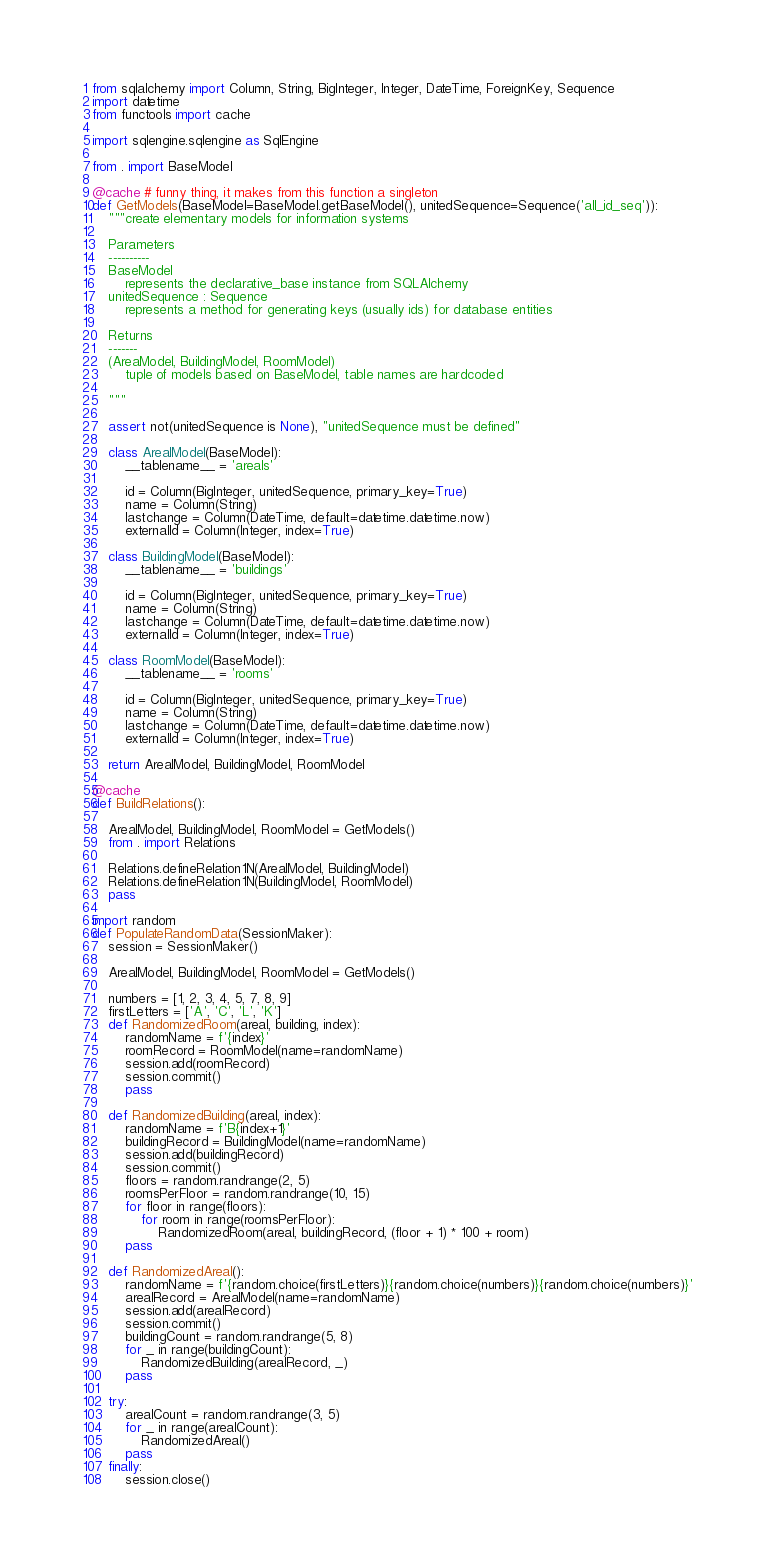<code> <loc_0><loc_0><loc_500><loc_500><_Python_>from sqlalchemy import Column, String, BigInteger, Integer, DateTime, ForeignKey, Sequence
import datetime
from functools import cache

import sqlengine.sqlengine as SqlEngine

from . import BaseModel

@cache # funny thing, it makes from this function a singleton
def GetModels(BaseModel=BaseModel.getBaseModel(), unitedSequence=Sequence('all_id_seq')):
    """create elementary models for information systems

    Parameters
    ----------
    BaseModel
        represents the declarative_base instance from SQLAlchemy
    unitedSequence : Sequence
        represents a method for generating keys (usually ids) for database entities

    Returns
    -------
    (AreaModel, BuildingModel, RoomModel)
        tuple of models based on BaseModel, table names are hardcoded

    """

    assert not(unitedSequence is None), "unitedSequence must be defined"
    
    class ArealModel(BaseModel):
        __tablename__ = 'areals'

        id = Column(BigInteger, unitedSequence, primary_key=True)
        name = Column(String)
        lastchange = Column(DateTime, default=datetime.datetime.now)
        externalId = Column(Integer, index=True)

    class BuildingModel(BaseModel):
        __tablename__ = 'buildings'

        id = Column(BigInteger, unitedSequence, primary_key=True)
        name = Column(String)
        lastchange = Column(DateTime, default=datetime.datetime.now)
        externalId = Column(Integer, index=True)

    class RoomModel(BaseModel):
        __tablename__ = 'rooms'
        
        id = Column(BigInteger, unitedSequence, primary_key=True)
        name = Column(String)
        lastchange = Column(DateTime, default=datetime.datetime.now)
        externalId = Column(Integer, index=True)

    return ArealModel, BuildingModel, RoomModel

@cache
def BuildRelations():

    ArealModel, BuildingModel, RoomModel = GetModels()
    from . import Relations 

    Relations.defineRelation1N(ArealModel, BuildingModel)
    Relations.defineRelation1N(BuildingModel, RoomModel)
    pass

import random
def PopulateRandomData(SessionMaker):
    session = SessionMaker()
    
    ArealModel, BuildingModel, RoomModel = GetModels()

    numbers = [1, 2, 3, 4, 5, 7, 8, 9]
    firstLetters = ['A', 'C', 'L', 'K']
    def RandomizedRoom(areal, building, index):
        randomName = f'{index}'
        roomRecord = RoomModel(name=randomName)
        session.add(roomRecord)
        session.commit()
        pass

    def RandomizedBuilding(areal, index):
        randomName = f'B{index+1}'
        buildingRecord = BuildingModel(name=randomName)
        session.add(buildingRecord)
        session.commit()
        floors = random.randrange(2, 5)
        roomsPerFloor = random.randrange(10, 15)
        for floor in range(floors):
            for room in range(roomsPerFloor):
                RandomizedRoom(areal, buildingRecord, (floor + 1) * 100 + room)
        pass

    def RandomizedAreal():
        randomName = f'{random.choice(firstLetters)}{random.choice(numbers)}{random.choice(numbers)}'
        arealRecord = ArealModel(name=randomName)
        session.add(arealRecord)
        session.commit()
        buildingCount = random.randrange(5, 8)
        for _ in range(buildingCount):
            RandomizedBuilding(arealRecord, _)
        pass

    try:
        arealCount = random.randrange(3, 5)
        for _ in range(arealCount):
            RandomizedAreal()
        pass
    finally:
        session.close()</code> 